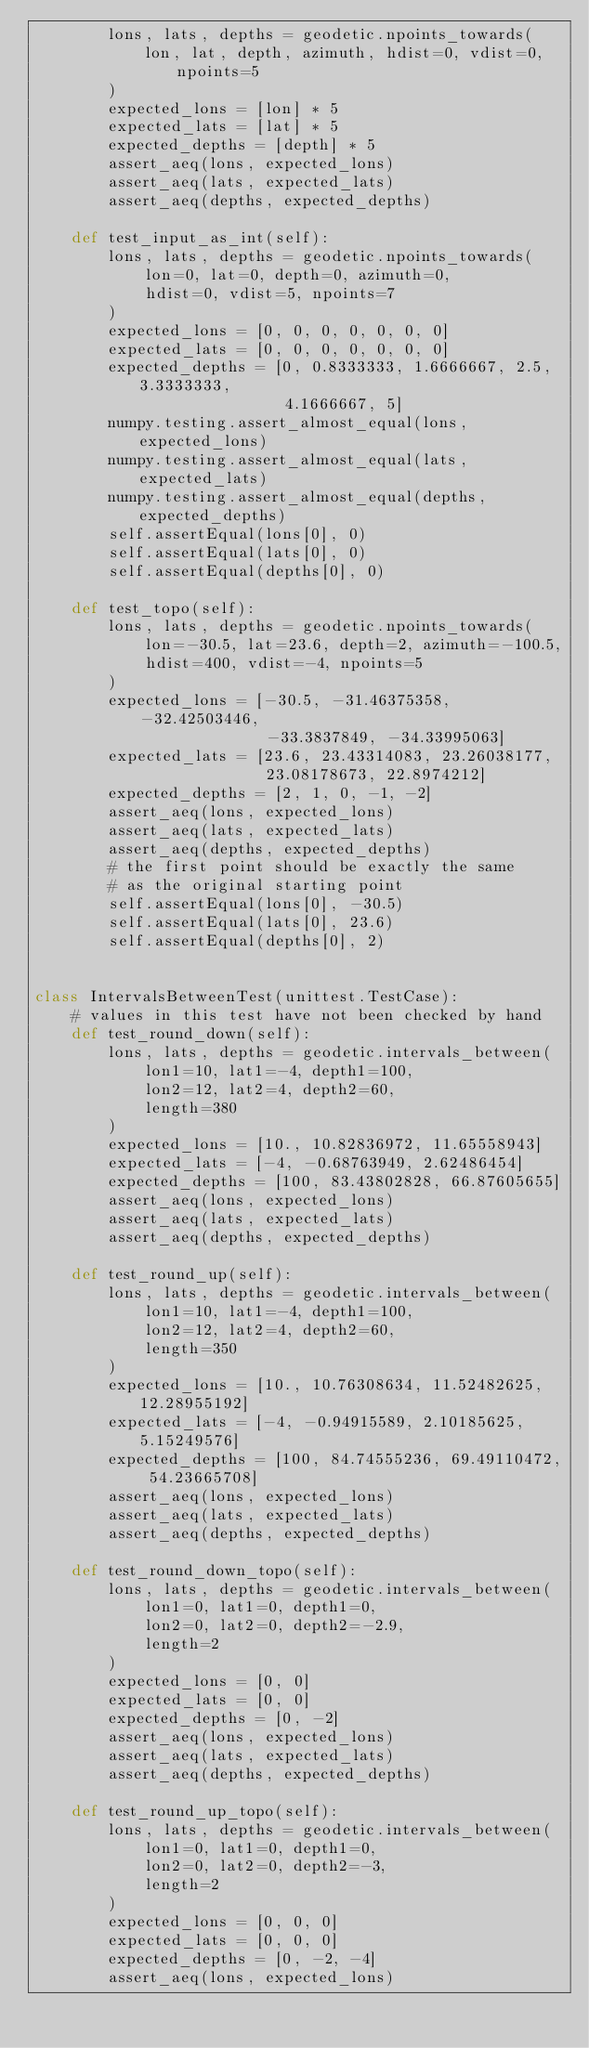<code> <loc_0><loc_0><loc_500><loc_500><_Python_>        lons, lats, depths = geodetic.npoints_towards(
            lon, lat, depth, azimuth, hdist=0, vdist=0, npoints=5
        )
        expected_lons = [lon] * 5
        expected_lats = [lat] * 5
        expected_depths = [depth] * 5
        assert_aeq(lons, expected_lons)
        assert_aeq(lats, expected_lats)
        assert_aeq(depths, expected_depths)

    def test_input_as_int(self):
        lons, lats, depths = geodetic.npoints_towards(
            lon=0, lat=0, depth=0, azimuth=0,
            hdist=0, vdist=5, npoints=7
        )
        expected_lons = [0, 0, 0, 0, 0, 0, 0]
        expected_lats = [0, 0, 0, 0, 0, 0, 0]
        expected_depths = [0, 0.8333333, 1.6666667, 2.5, 3.3333333,
                           4.1666667, 5]
        numpy.testing.assert_almost_equal(lons, expected_lons)
        numpy.testing.assert_almost_equal(lats, expected_lats)
        numpy.testing.assert_almost_equal(depths, expected_depths)
        self.assertEqual(lons[0], 0)
        self.assertEqual(lats[0], 0)
        self.assertEqual(depths[0], 0)

    def test_topo(self):
        lons, lats, depths = geodetic.npoints_towards(
            lon=-30.5, lat=23.6, depth=2, azimuth=-100.5,
            hdist=400, vdist=-4, npoints=5
        )
        expected_lons = [-30.5, -31.46375358, -32.42503446,
                         -33.3837849, -34.33995063]
        expected_lats = [23.6, 23.43314083, 23.26038177,
                         23.08178673, 22.8974212]
        expected_depths = [2, 1, 0, -1, -2]
        assert_aeq(lons, expected_lons)
        assert_aeq(lats, expected_lats)
        assert_aeq(depths, expected_depths)
        # the first point should be exactly the same
        # as the original starting point
        self.assertEqual(lons[0], -30.5)
        self.assertEqual(lats[0], 23.6)
        self.assertEqual(depths[0], 2)


class IntervalsBetweenTest(unittest.TestCase):
    # values in this test have not been checked by hand
    def test_round_down(self):
        lons, lats, depths = geodetic.intervals_between(
            lon1=10, lat1=-4, depth1=100,
            lon2=12, lat2=4, depth2=60,
            length=380
        )
        expected_lons = [10., 10.82836972, 11.65558943]
        expected_lats = [-4, -0.68763949, 2.62486454]
        expected_depths = [100, 83.43802828, 66.87605655]
        assert_aeq(lons, expected_lons)
        assert_aeq(lats, expected_lats)
        assert_aeq(depths, expected_depths)

    def test_round_up(self):
        lons, lats, depths = geodetic.intervals_between(
            lon1=10, lat1=-4, depth1=100,
            lon2=12, lat2=4, depth2=60,
            length=350
        )
        expected_lons = [10., 10.76308634, 11.52482625, 12.28955192]
        expected_lats = [-4, -0.94915589, 2.10185625, 5.15249576]
        expected_depths = [100, 84.74555236, 69.49110472, 54.23665708]
        assert_aeq(lons, expected_lons)
        assert_aeq(lats, expected_lats)
        assert_aeq(depths, expected_depths)

    def test_round_down_topo(self):
        lons, lats, depths = geodetic.intervals_between(
            lon1=0, lat1=0, depth1=0,
            lon2=0, lat2=0, depth2=-2.9,
            length=2
        )
        expected_lons = [0, 0]
        expected_lats = [0, 0]
        expected_depths = [0, -2]
        assert_aeq(lons, expected_lons)
        assert_aeq(lats, expected_lats)
        assert_aeq(depths, expected_depths)

    def test_round_up_topo(self):
        lons, lats, depths = geodetic.intervals_between(
            lon1=0, lat1=0, depth1=0,
            lon2=0, lat2=0, depth2=-3,
            length=2
        )
        expected_lons = [0, 0, 0]
        expected_lats = [0, 0, 0]
        expected_depths = [0, -2, -4]
        assert_aeq(lons, expected_lons)</code> 